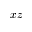<formula> <loc_0><loc_0><loc_500><loc_500>x z</formula> 